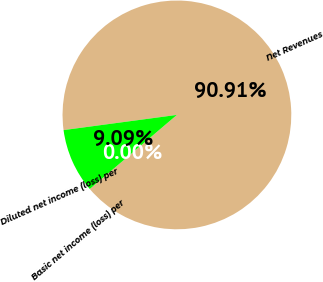<chart> <loc_0><loc_0><loc_500><loc_500><pie_chart><fcel>Net Revenues<fcel>Basic net income (loss) per<fcel>Diluted net income (loss) per<nl><fcel>90.91%<fcel>0.0%<fcel>9.09%<nl></chart> 